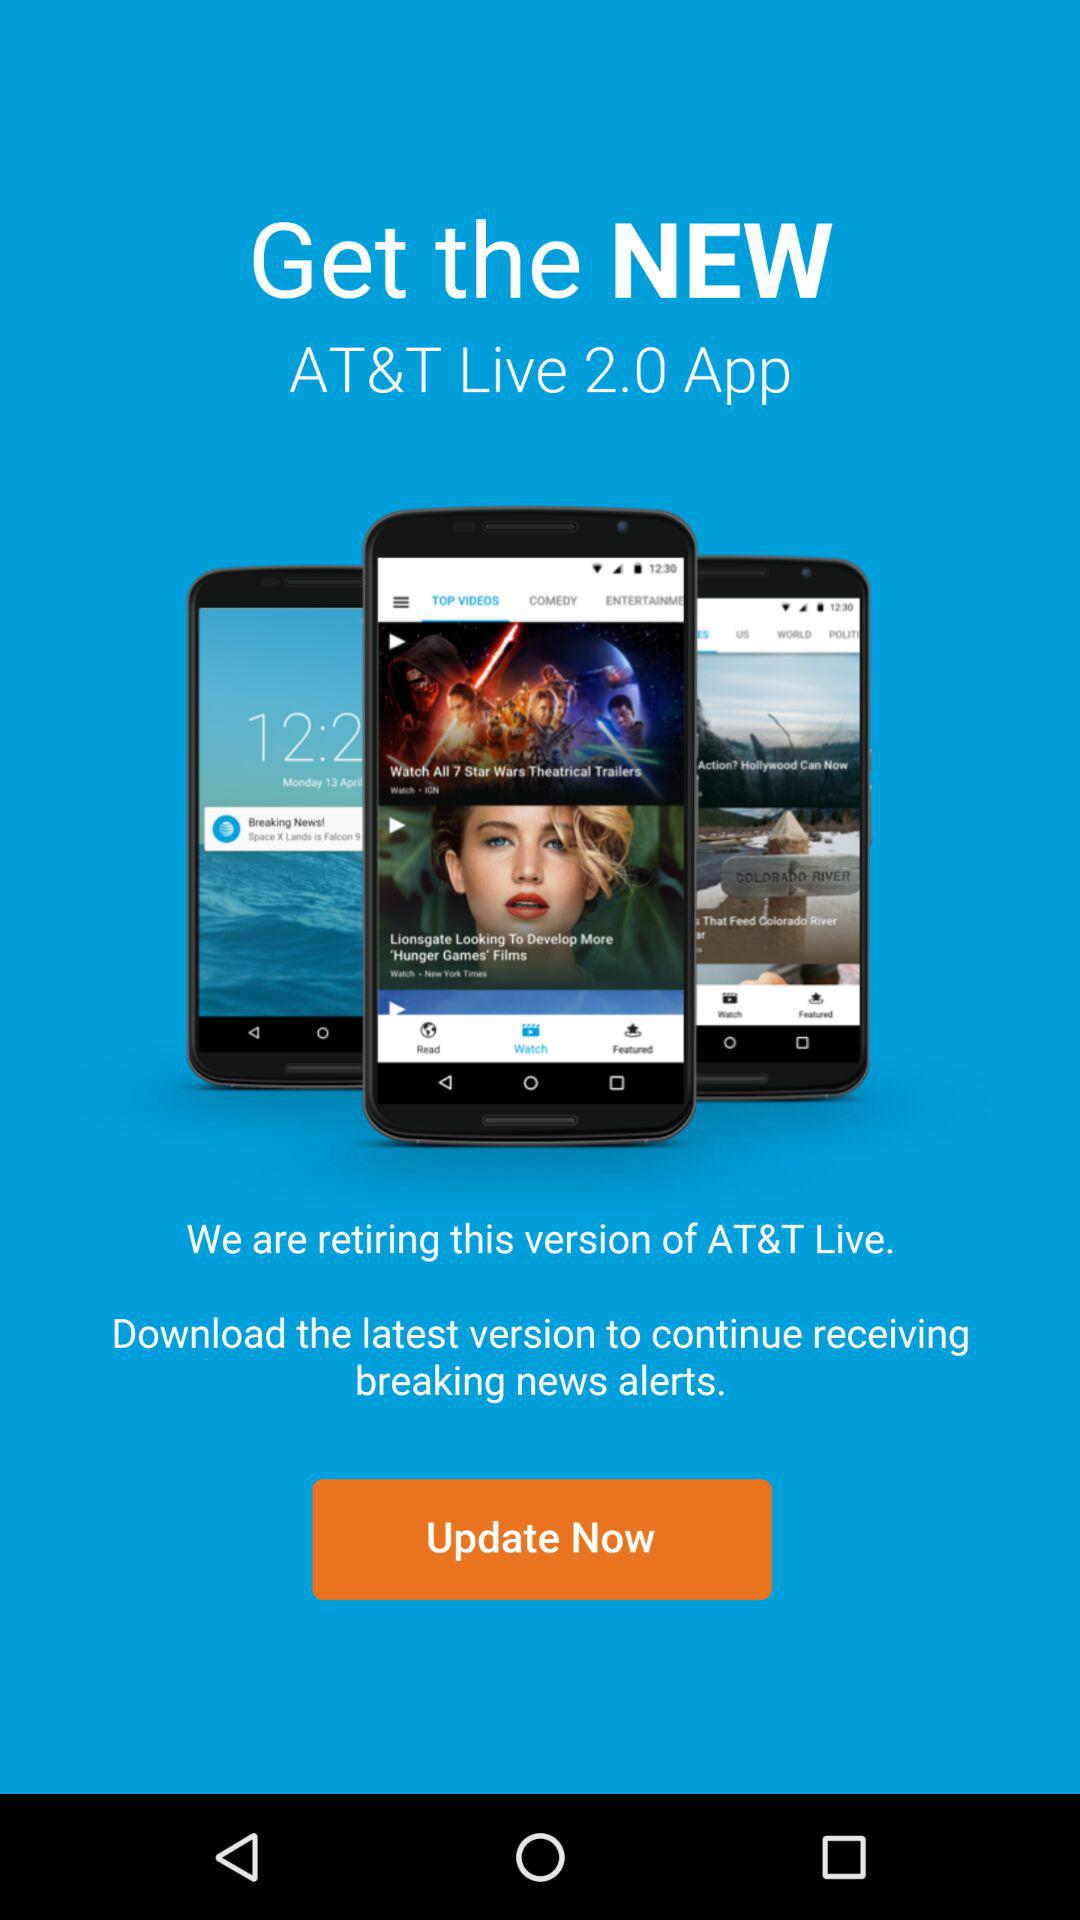What is the name of the application? The name of the application is "AT&T Live 2.0". 